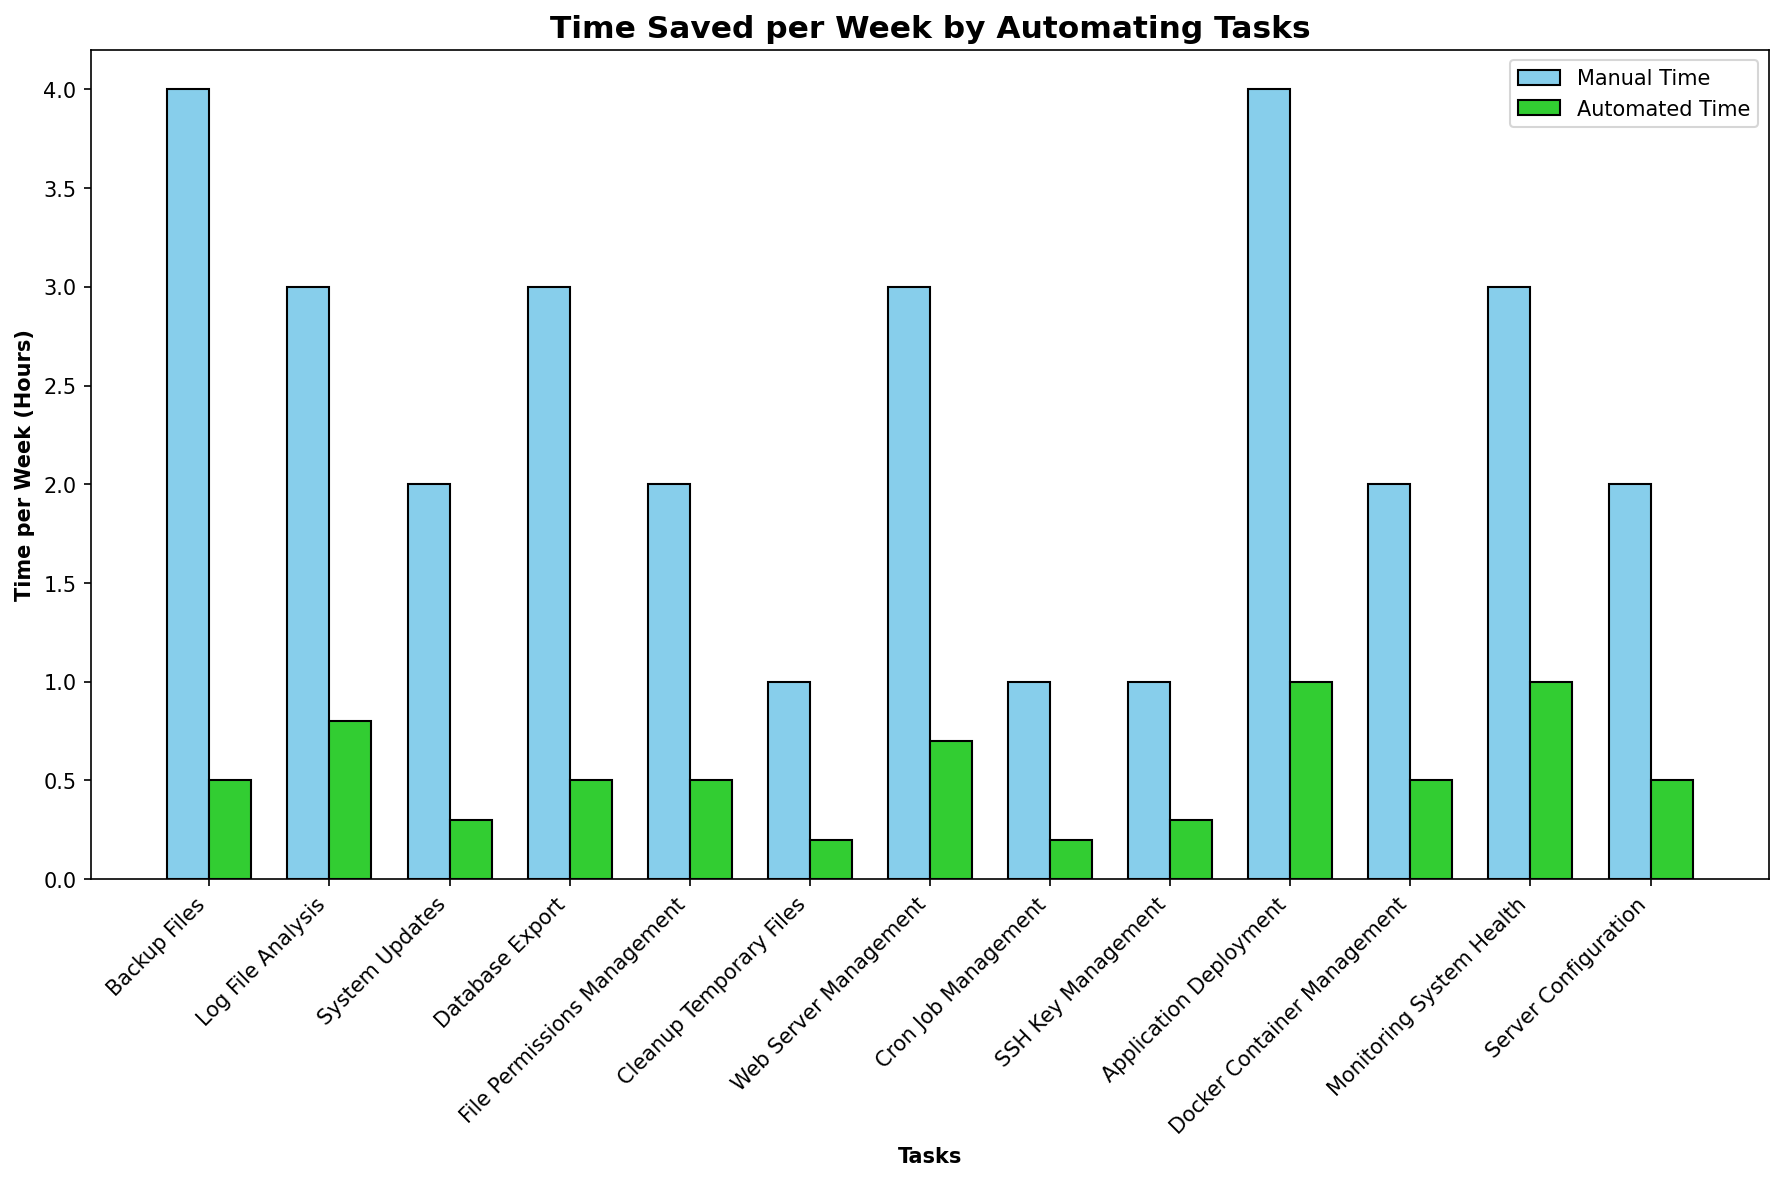How much time can you save per week by automating the "Backup Files" task? The "Backup Files" task takes 4 hours per week manually and 0.5 hours per week when automated. The time saved is the difference between these two values: 4 - 0.5 = 3.5 hours.
Answer: 3.5 hours Which task shows the most significant reduction in time when automated? To find this, compare the time saved for each task by looking at the difference between manual and automated times. The "Application Deployment" task saves the most time, reducing from 4 hours to 1 hour, a difference of 3 hours.
Answer: Application Deployment What is the total manual time per week for all the tasks combined? Sum the manual time for all the tasks: 4 + 3 + 2 + 3 + 2 + 1 + 3 + 1 + 1 + 4 + 2 + 3 + 2 = 31 hours.
Answer: 31 hours What is the average automated time per week for these tasks? Sum the automated times for all tasks and divide by the number of tasks: (0.5 + 0.8 + 0.3 + 0.5 + 0.5 + 0.2 + 0.7 + 0.2 + 0.3 + 1 + 0.5 + 1 + 0.5) / 13 = 7.7 / 13 ≈ 0.59 hours.
Answer: 0.59 hours Which task saves the least amount of time when automated? This requires finding the smallest difference between manual and automated times. The tasks "Cleanup Temporary Files," "Cron Job Management," and "SSH Key Management" each save 0.8 hours, which is the smallest time saved.
Answer: Cleanup Temporary Files, Cron Job Management, SSH Key Management How much time per week is saved in total by automating all the tasks? Subtract the total automated time from the total manual time. Total manual time: 31 hours. Total automated time: 7.7 hours. 31 - 7.7 = 23.3 hours.
Answer: 23.3 hours If you only automate "Log File Analysis" and "System Updates," how much total time would you save per week? Calculate the time saved for each task and sum the time saved. "Log File Analysis" saves 3 - 0.8 = 2.2 hours, and "System Updates" saves 2 - 0.3 = 1.7 hours. So, 2.2 + 1.7 = 3.9 hours.
Answer: 3.9 hours Which tasks take more than 2 hours to perform manually per week? Look for tasks with manual time greater than 2 hours. These tasks are "Backup Files" (4 hours), "Log File Analysis" (3 hours), "Database Export" (3 hours), "Web Server Management" (3 hours), "Application Deployment" (4 hours), and "Monitoring System Health" (3 hours).
Answer: Backup Files, Log File Analysis, Database Export, Web Server Management, Application Deployment, Monitoring System Health By how much is the manual time higher than the automated time on average across all tasks? Calculate the average manual time by summing the manual times and dividing by the number of tasks, and do the same for the automated times. Average manual time: 31 / 13 ≈ 2.38 hours. Average automated time: 7.7 / 13 ≈ 0.59 hours. The difference is 2.38 - 0.59 ≈ 1.79 hours.
Answer: 1.79 hours 